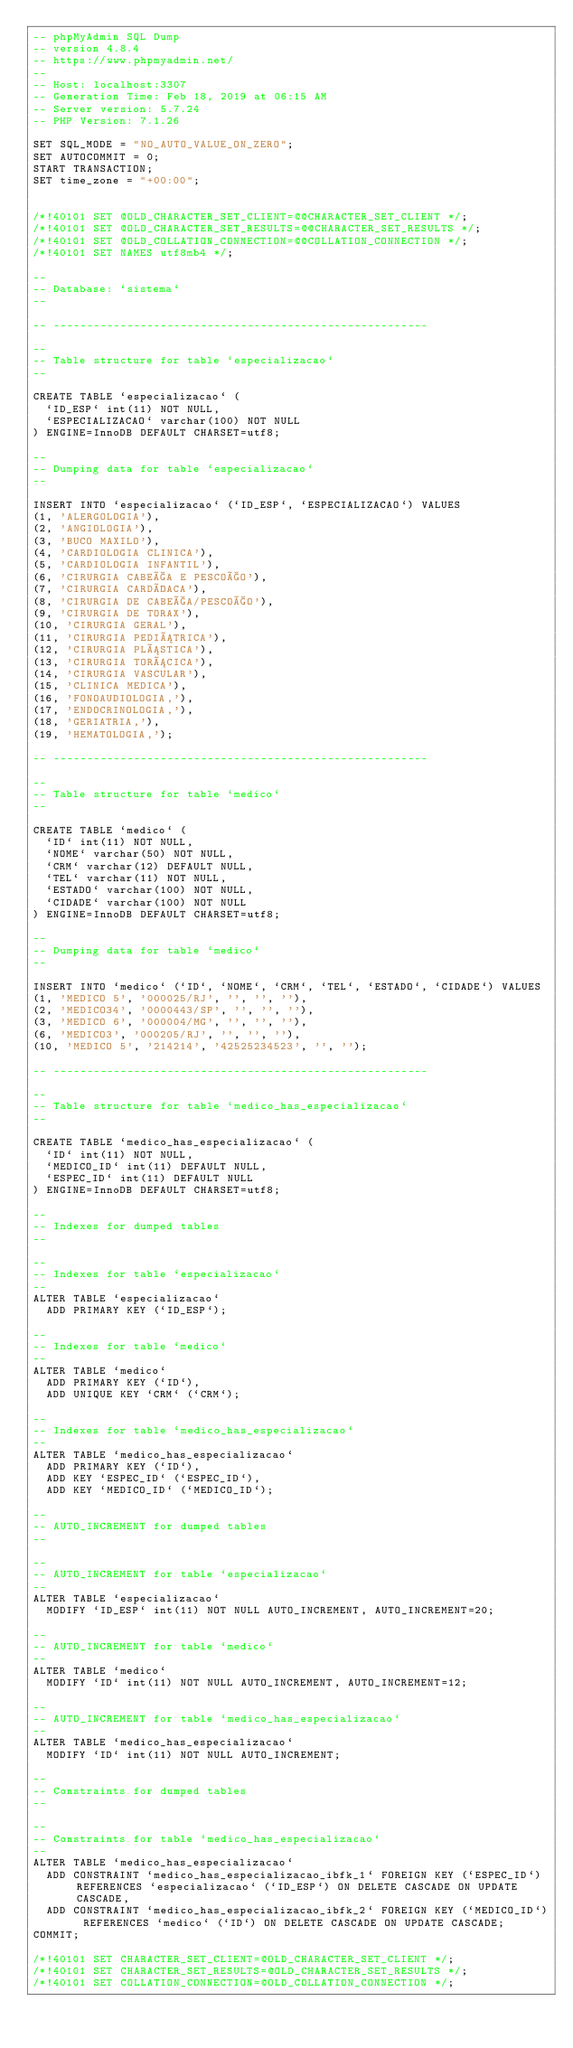Convert code to text. <code><loc_0><loc_0><loc_500><loc_500><_SQL_>-- phpMyAdmin SQL Dump
-- version 4.8.4
-- https://www.phpmyadmin.net/
--
-- Host: localhost:3307
-- Generation Time: Feb 18, 2019 at 06:15 AM
-- Server version: 5.7.24
-- PHP Version: 7.1.26

SET SQL_MODE = "NO_AUTO_VALUE_ON_ZERO";
SET AUTOCOMMIT = 0;
START TRANSACTION;
SET time_zone = "+00:00";


/*!40101 SET @OLD_CHARACTER_SET_CLIENT=@@CHARACTER_SET_CLIENT */;
/*!40101 SET @OLD_CHARACTER_SET_RESULTS=@@CHARACTER_SET_RESULTS */;
/*!40101 SET @OLD_COLLATION_CONNECTION=@@COLLATION_CONNECTION */;
/*!40101 SET NAMES utf8mb4 */;

--
-- Database: `sistema`
--

-- --------------------------------------------------------

--
-- Table structure for table `especializacao`
--

CREATE TABLE `especializacao` (
  `ID_ESP` int(11) NOT NULL,
  `ESPECIALIZACAO` varchar(100) NOT NULL
) ENGINE=InnoDB DEFAULT CHARSET=utf8;

--
-- Dumping data for table `especializacao`
--

INSERT INTO `especializacao` (`ID_ESP`, `ESPECIALIZACAO`) VALUES
(1, 'ALERGOLOGIA'),
(2, 'ANGIOLOGIA'),
(3, 'BUCO MAXILO'),
(4, 'CARDIOLOGIA CLINICA'),
(5, 'CARDIOLOGIA INFANTIL'),
(6, 'CIRURGIA CABEÇA E PESCOÇO'),
(7, 'CIRURGIA CARDÍACA'),
(8, 'CIRURGIA DE CABEÇA/PESCOÇO'),
(9, 'CIRURGIA DE TORAX'),
(10, 'CIRURGIA GERAL'),
(11, 'CIRURGIA PEDIÁTRICA'),
(12, 'CIRURGIA PLÁSTICA'),
(13, 'CIRURGIA TORÁCICA'),
(14, 'CIRURGIA VASCULAR'),
(15, 'CLINICA MEDICA'),
(16, 'FONOAUDIOLOGIA,'),
(17, 'ENDOCRINOLOGIA,'),
(18, 'GERIATRIA,'),
(19, 'HEMATOLOGIA,');

-- --------------------------------------------------------

--
-- Table structure for table `medico`
--

CREATE TABLE `medico` (
  `ID` int(11) NOT NULL,
  `NOME` varchar(50) NOT NULL,
  `CRM` varchar(12) DEFAULT NULL,
  `TEL` varchar(11) NOT NULL,
  `ESTADO` varchar(100) NOT NULL,
  `CIDADE` varchar(100) NOT NULL
) ENGINE=InnoDB DEFAULT CHARSET=utf8;

--
-- Dumping data for table `medico`
--

INSERT INTO `medico` (`ID`, `NOME`, `CRM`, `TEL`, `ESTADO`, `CIDADE`) VALUES
(1, 'MEDICO 5', '000025/RJ', '', '', ''),
(2, 'MEDICO34', '0000443/SP', '', '', ''),
(3, 'MEDICO 6', '000004/MG', '', '', ''),
(6, 'MEDICO3', '000205/RJ', '', '', ''),
(10, 'MEDICO 5', '214214', '42525234523', '', '');

-- --------------------------------------------------------

--
-- Table structure for table `medico_has_especializacao`
--

CREATE TABLE `medico_has_especializacao` (
  `ID` int(11) NOT NULL,
  `MEDICO_ID` int(11) DEFAULT NULL,
  `ESPEC_ID` int(11) DEFAULT NULL
) ENGINE=InnoDB DEFAULT CHARSET=utf8;

--
-- Indexes for dumped tables
--

--
-- Indexes for table `especializacao`
--
ALTER TABLE `especializacao`
  ADD PRIMARY KEY (`ID_ESP`);

--
-- Indexes for table `medico`
--
ALTER TABLE `medico`
  ADD PRIMARY KEY (`ID`),
  ADD UNIQUE KEY `CRM` (`CRM`);

--
-- Indexes for table `medico_has_especializacao`
--
ALTER TABLE `medico_has_especializacao`
  ADD PRIMARY KEY (`ID`),
  ADD KEY `ESPEC_ID` (`ESPEC_ID`),
  ADD KEY `MEDICO_ID` (`MEDICO_ID`);

--
-- AUTO_INCREMENT for dumped tables
--

--
-- AUTO_INCREMENT for table `especializacao`
--
ALTER TABLE `especializacao`
  MODIFY `ID_ESP` int(11) NOT NULL AUTO_INCREMENT, AUTO_INCREMENT=20;

--
-- AUTO_INCREMENT for table `medico`
--
ALTER TABLE `medico`
  MODIFY `ID` int(11) NOT NULL AUTO_INCREMENT, AUTO_INCREMENT=12;

--
-- AUTO_INCREMENT for table `medico_has_especializacao`
--
ALTER TABLE `medico_has_especializacao`
  MODIFY `ID` int(11) NOT NULL AUTO_INCREMENT;

--
-- Constraints for dumped tables
--

--
-- Constraints for table `medico_has_especializacao`
--
ALTER TABLE `medico_has_especializacao`
  ADD CONSTRAINT `medico_has_especializacao_ibfk_1` FOREIGN KEY (`ESPEC_ID`) REFERENCES `especializacao` (`ID_ESP`) ON DELETE CASCADE ON UPDATE CASCADE,
  ADD CONSTRAINT `medico_has_especializacao_ibfk_2` FOREIGN KEY (`MEDICO_ID`) REFERENCES `medico` (`ID`) ON DELETE CASCADE ON UPDATE CASCADE;
COMMIT;

/*!40101 SET CHARACTER_SET_CLIENT=@OLD_CHARACTER_SET_CLIENT */;
/*!40101 SET CHARACTER_SET_RESULTS=@OLD_CHARACTER_SET_RESULTS */;
/*!40101 SET COLLATION_CONNECTION=@OLD_COLLATION_CONNECTION */;
</code> 